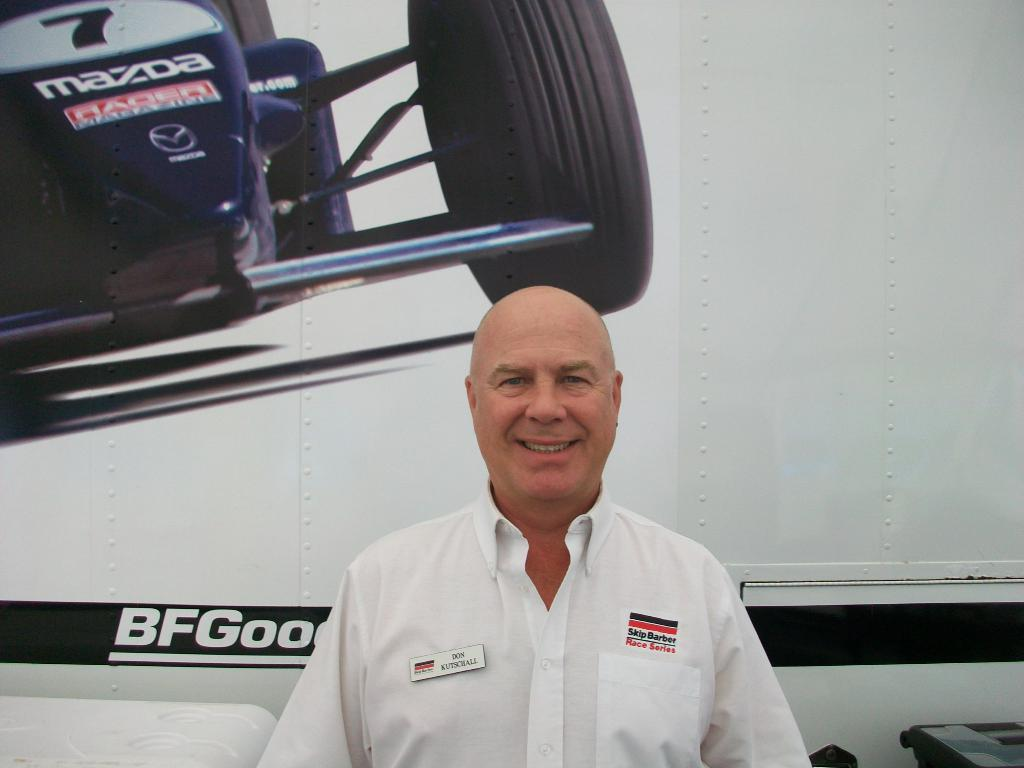Provide a one-sentence caption for the provided image. a man smiling with Skip Barber Race series written on his shirt. 